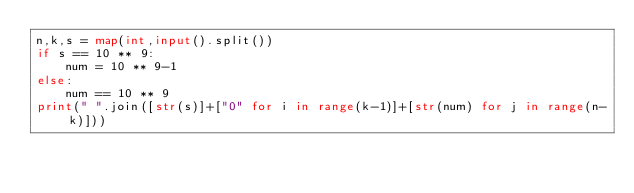Convert code to text. <code><loc_0><loc_0><loc_500><loc_500><_Python_>n,k,s = map(int,input().split())
if s == 10 ** 9:
    num = 10 ** 9-1
else:
    num == 10 ** 9
print(" ".join([str(s)]+["0" for i in range(k-1)]+[str(num) for j in range(n-k)]))</code> 